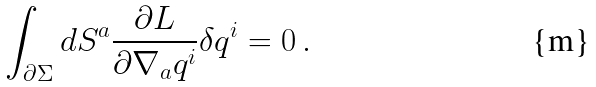<formula> <loc_0><loc_0><loc_500><loc_500>\int _ { \partial \Sigma } d S ^ { a } \frac { \partial L } { \partial \nabla _ { a } q ^ { i } } \delta q ^ { i } = 0 \, .</formula> 